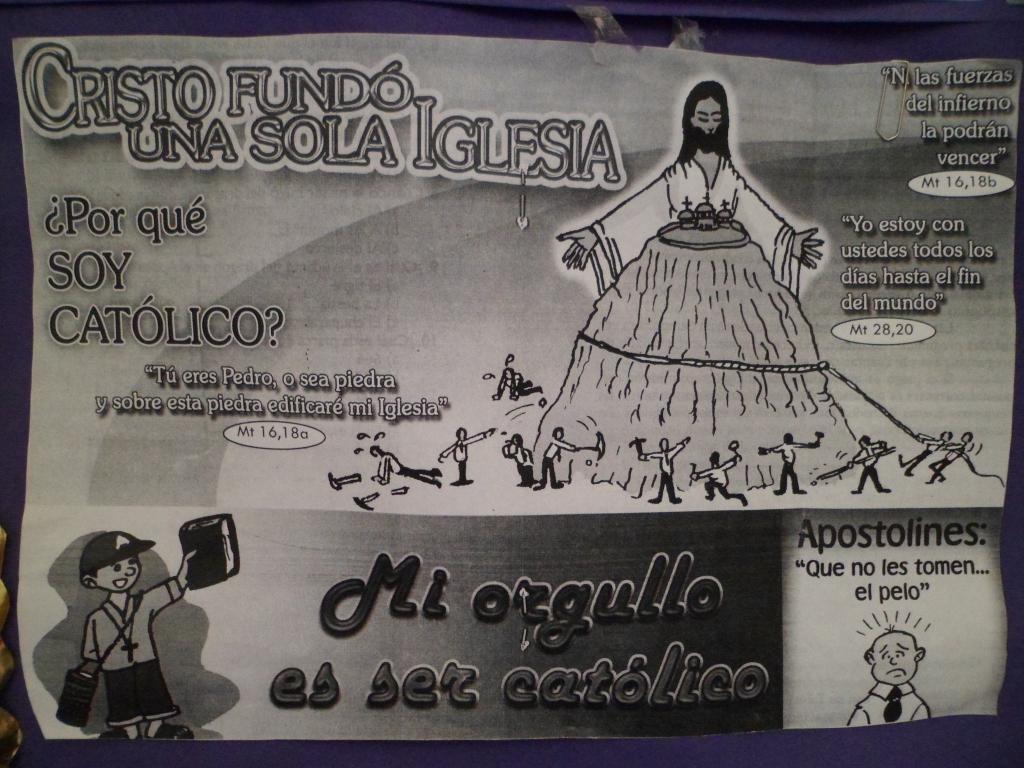In one or two sentences, can you explain what this image depicts? In this image we can see a poster. On this poster we can see pictures and something is written on it. 